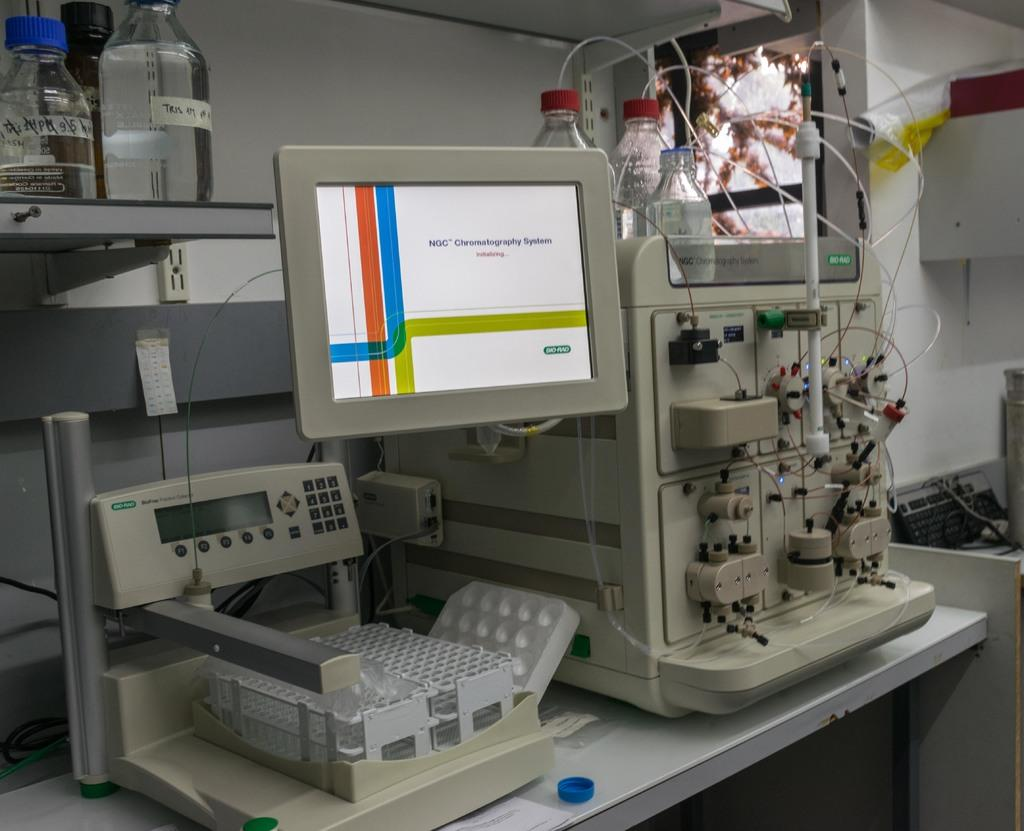What is the primary object visible on the screen in the image? The provided facts do not specify what is on the screen, so we cannot answer this question definitively. What is the glass used for in the image? The provided facts do not specify the purpose of the glass, so we cannot answer this question definitively. What type of machine is on the floor in the image? The provided facts do not specify the type of machine, so we cannot answer this question definitively. What type of shoe is being used for digestion in the image? There is no shoe or reference to digestion present in the image. 